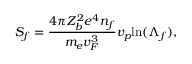<formula> <loc_0><loc_0><loc_500><loc_500>S _ { f } = \frac { 4 \pi Z _ { b } ^ { 2 } e ^ { 4 } n _ { f } } { m _ { e } v _ { F } ^ { 3 } } v _ { p } \ln ( \Lambda _ { f } ) ,</formula> 